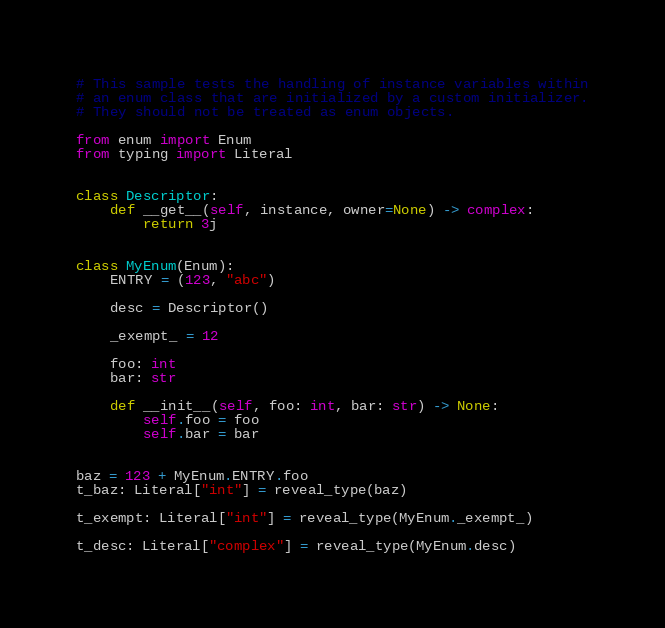<code> <loc_0><loc_0><loc_500><loc_500><_Python_># This sample tests the handling of instance variables within
# an enum class that are initialized by a custom initializer.
# They should not be treated as enum objects.

from enum import Enum
from typing import Literal


class Descriptor:
    def __get__(self, instance, owner=None) -> complex:
        return 3j


class MyEnum(Enum):
    ENTRY = (123, "abc")

    desc = Descriptor()

    _exempt_ = 12

    foo: int
    bar: str

    def __init__(self, foo: int, bar: str) -> None:
        self.foo = foo
        self.bar = bar


baz = 123 + MyEnum.ENTRY.foo
t_baz: Literal["int"] = reveal_type(baz)

t_exempt: Literal["int"] = reveal_type(MyEnum._exempt_)

t_desc: Literal["complex"] = reveal_type(MyEnum.desc)
</code> 